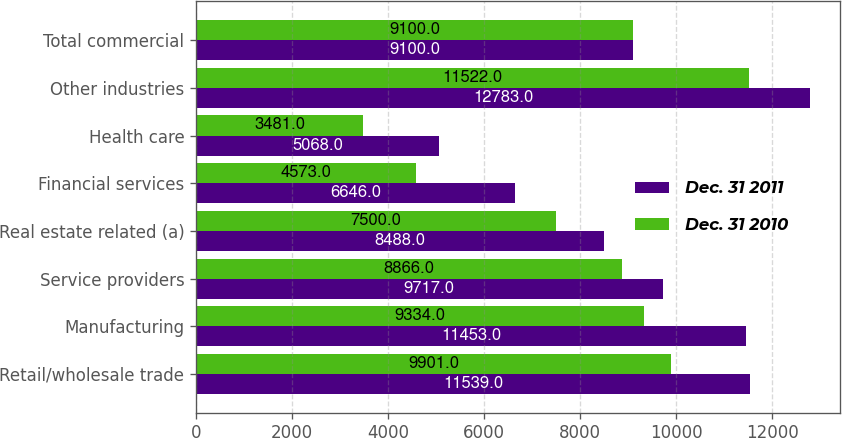Convert chart. <chart><loc_0><loc_0><loc_500><loc_500><stacked_bar_chart><ecel><fcel>Retail/wholesale trade<fcel>Manufacturing<fcel>Service providers<fcel>Real estate related (a)<fcel>Financial services<fcel>Health care<fcel>Other industries<fcel>Total commercial<nl><fcel>Dec. 31 2011<fcel>11539<fcel>11453<fcel>9717<fcel>8488<fcel>6646<fcel>5068<fcel>12783<fcel>9100<nl><fcel>Dec. 31 2010<fcel>9901<fcel>9334<fcel>8866<fcel>7500<fcel>4573<fcel>3481<fcel>11522<fcel>9100<nl></chart> 